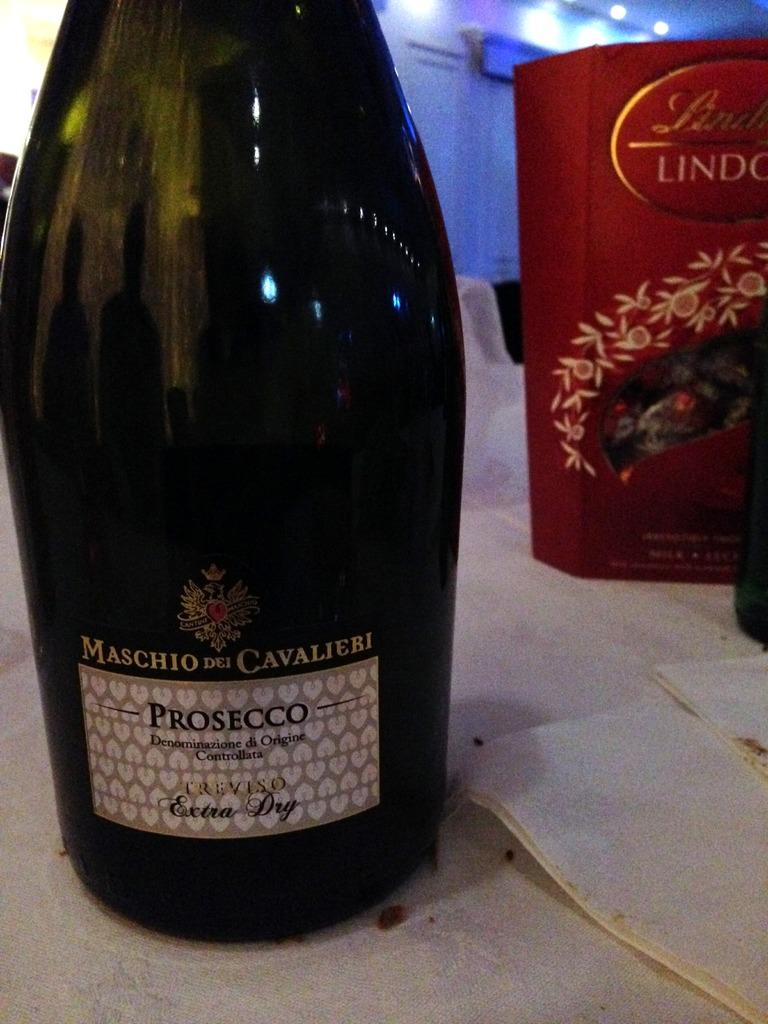<image>
Provide a brief description of the given image. Wine bottle of Maschio dei Cavalieri Prosecco next to box of Lindt Lindor holiday chocolates. 